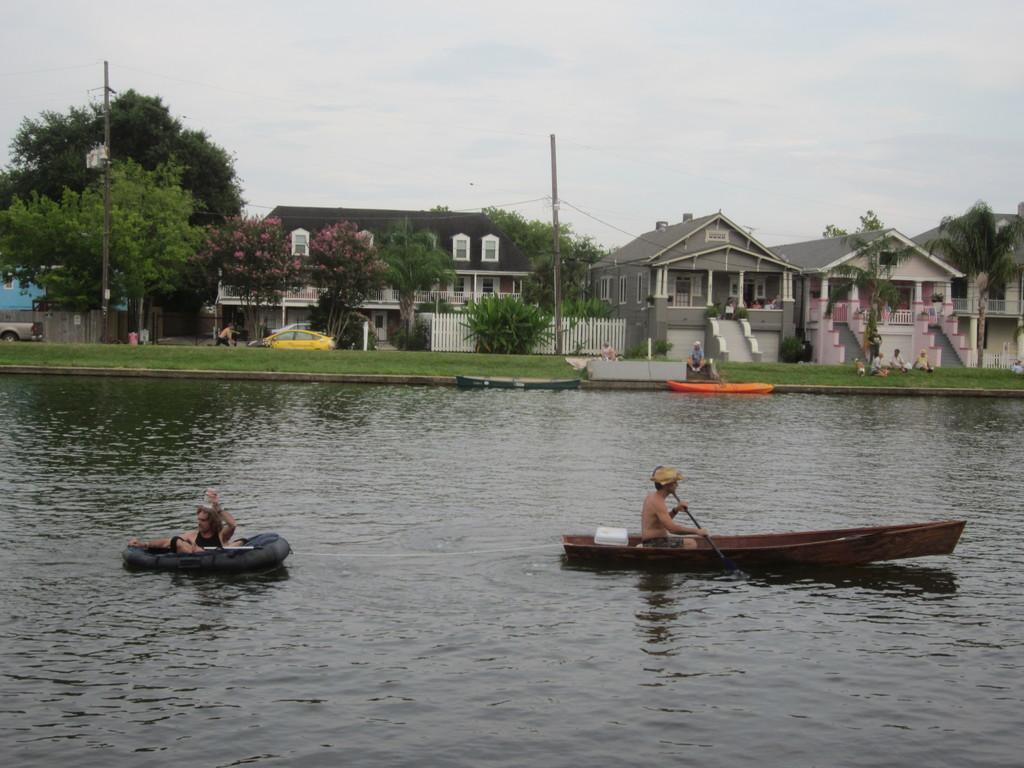In one or two sentences, can you explain what this image depicts? In this image we can see lake and two people are boating in different boat. Behind the lake, the land is full of grass. And building, tree and poles are there. The sky is full of clouds. 